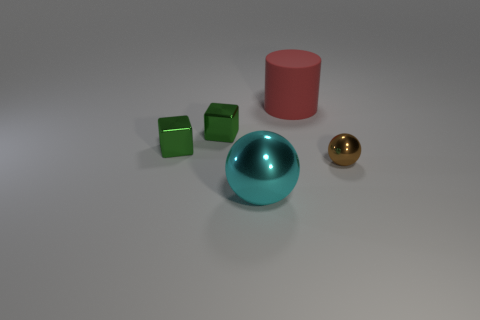Can you tell me what materials the objects in the image might be made of? Certainly! The largest sphere seems to feature a metallic surface, likely representing a material such as steel or aluminum given its reflective quality. The cube and cylindrical objects exhibit a matte finish, which suggests they could be composed of plastic or painted wood. 